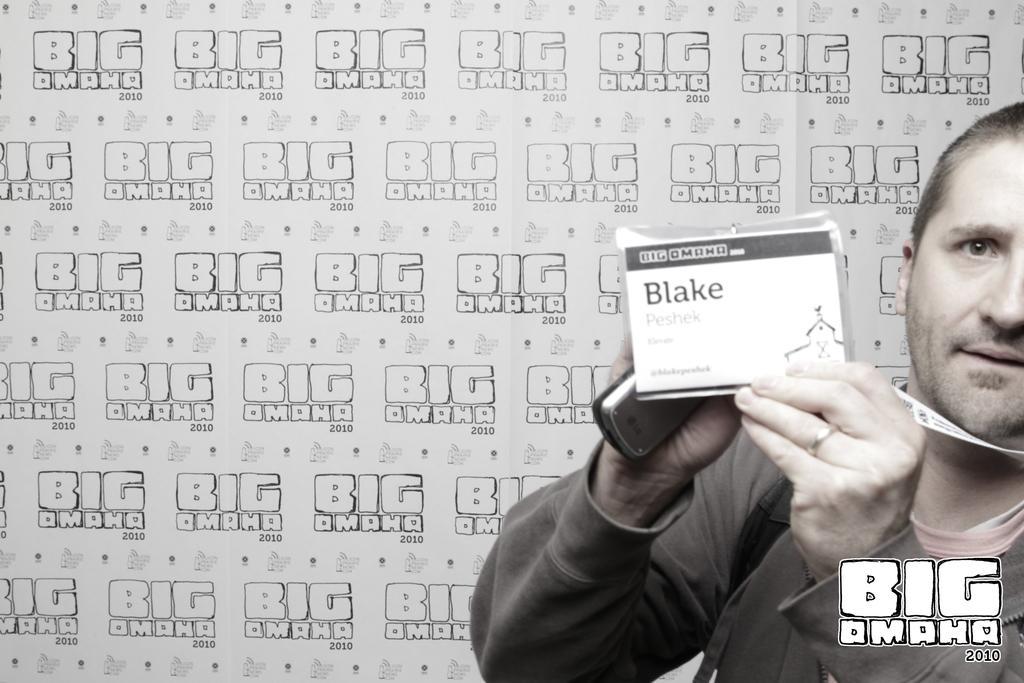In one or two sentences, can you explain what this image depicts? In this Image I can see the person holding the mobile and identification card. In the background there is a banner and something is written on it. 